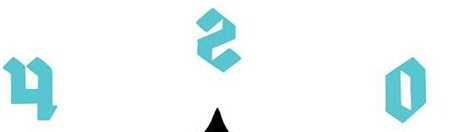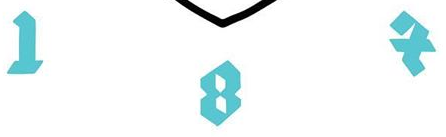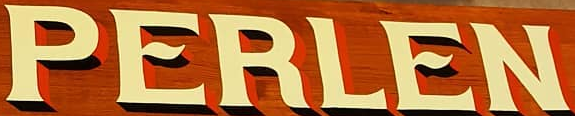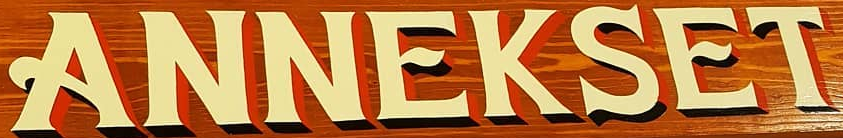Read the text content from these images in order, separated by a semicolon. osh; IBX; PERLEN; ANNEKSET 